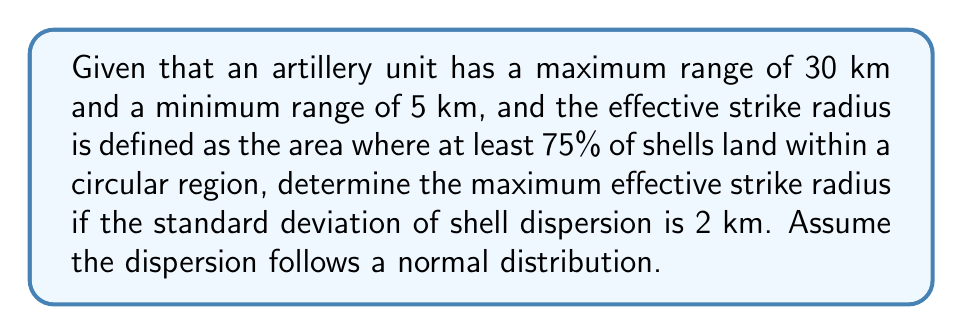Can you solve this math problem? To solve this problem, we'll follow these steps:

1) In a normal distribution, approximately 68% of the data falls within one standard deviation of the mean, 95% within two standard deviations, and 99.7% within three standard deviations.

2) We need to find the number of standard deviations that encompass 75% of the shells.

3) Using a z-score table or calculator, we find that 75% of the data in a normal distribution falls within ±1.15 standard deviations of the mean.

4) Given that the standard deviation of shell dispersion is 2 km, we can calculate the radius:

   $$r = 1.15 \times 2 \text{ km} = 2.3 \text{ km}$$

5) This radius represents the maximum effective strike radius, as it encompasses 75% of the shells.

6) We need to verify if this radius is within the artillery unit's range:
   
   Minimum range: 5 km < 2.3 km < 30 km : Maximum range

   The calculated radius is within the unit's operational range.

Therefore, the maximum effective strike radius is 2.3 km.
Answer: 2.3 km 